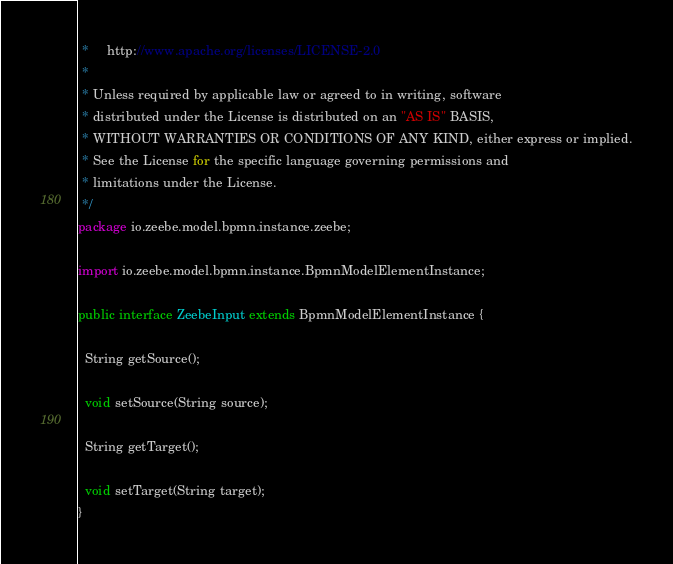Convert code to text. <code><loc_0><loc_0><loc_500><loc_500><_Java_> *     http://www.apache.org/licenses/LICENSE-2.0
 *
 * Unless required by applicable law or agreed to in writing, software
 * distributed under the License is distributed on an "AS IS" BASIS,
 * WITHOUT WARRANTIES OR CONDITIONS OF ANY KIND, either express or implied.
 * See the License for the specific language governing permissions and
 * limitations under the License.
 */
package io.zeebe.model.bpmn.instance.zeebe;

import io.zeebe.model.bpmn.instance.BpmnModelElementInstance;

public interface ZeebeInput extends BpmnModelElementInstance {

  String getSource();

  void setSource(String source);

  String getTarget();

  void setTarget(String target);
}
</code> 